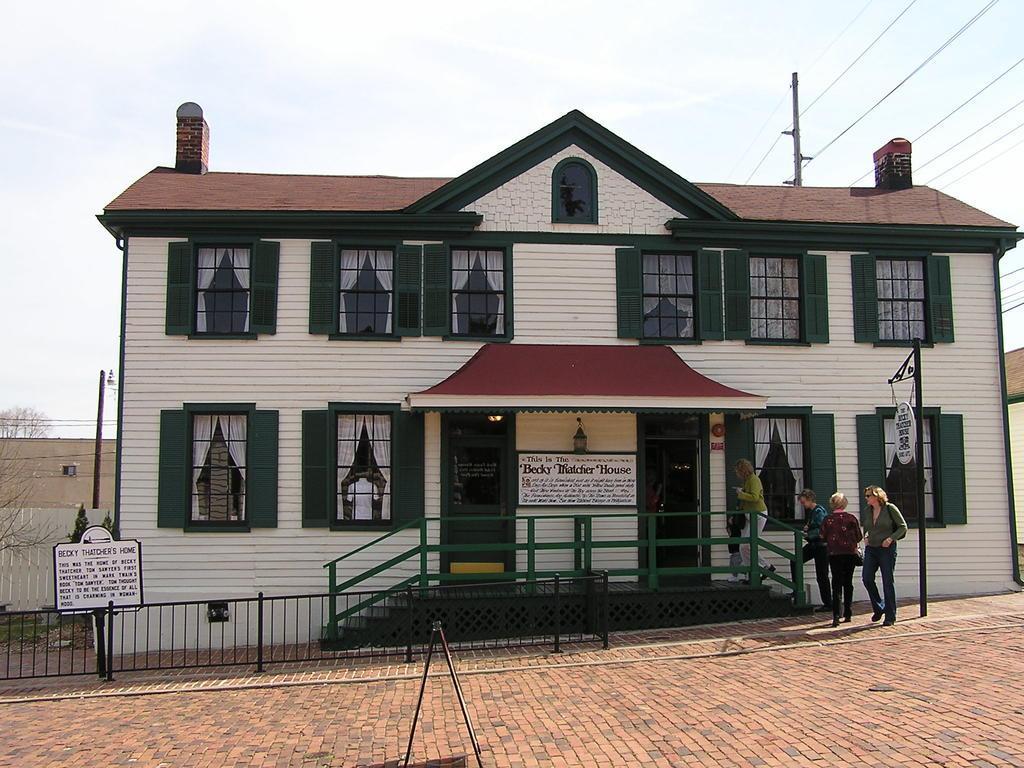Please provide a concise description of this image. In the foreground I can see five persons, board, fence, buildings and windows. In the background I can see a pole, wires and the sky. This image is taken may be during a sunny day. 